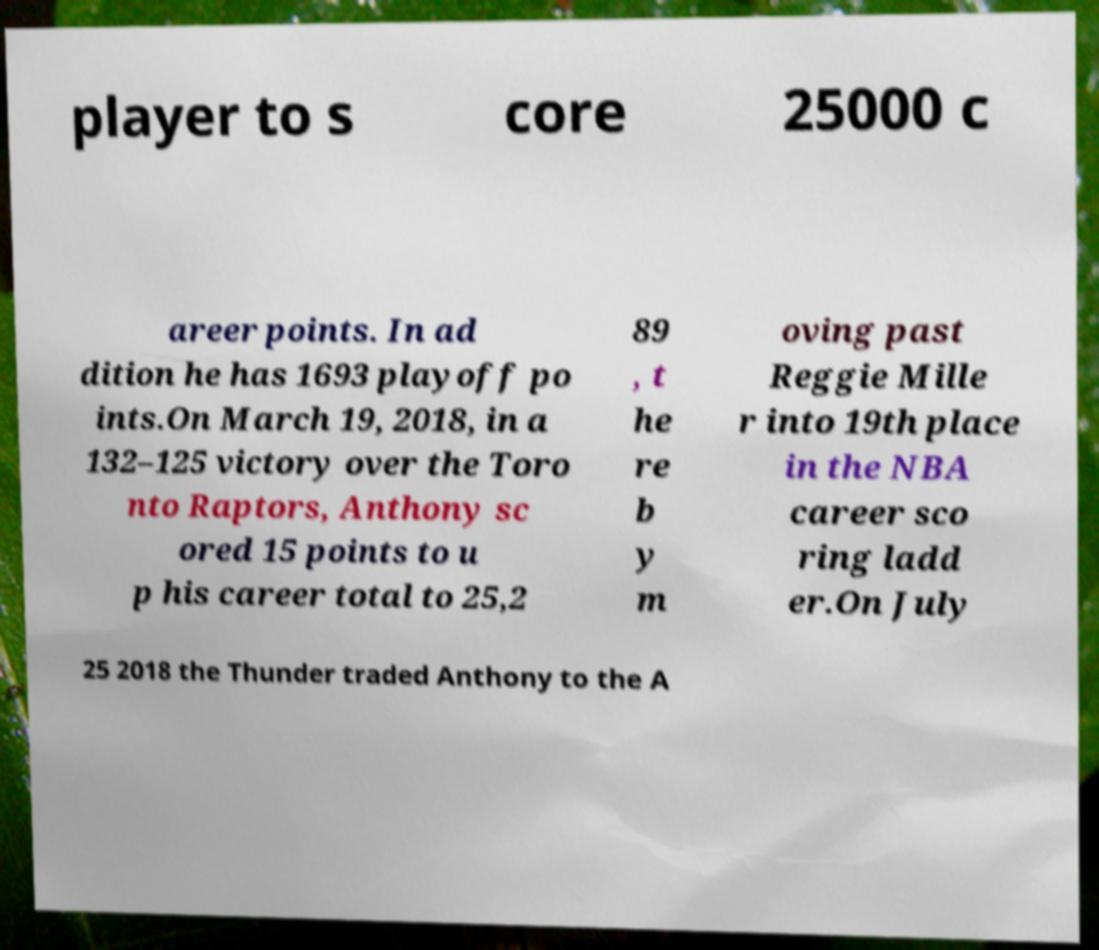Can you accurately transcribe the text from the provided image for me? player to s core 25000 c areer points. In ad dition he has 1693 playoff po ints.On March 19, 2018, in a 132–125 victory over the Toro nto Raptors, Anthony sc ored 15 points to u p his career total to 25,2 89 , t he re b y m oving past Reggie Mille r into 19th place in the NBA career sco ring ladd er.On July 25 2018 the Thunder traded Anthony to the A 